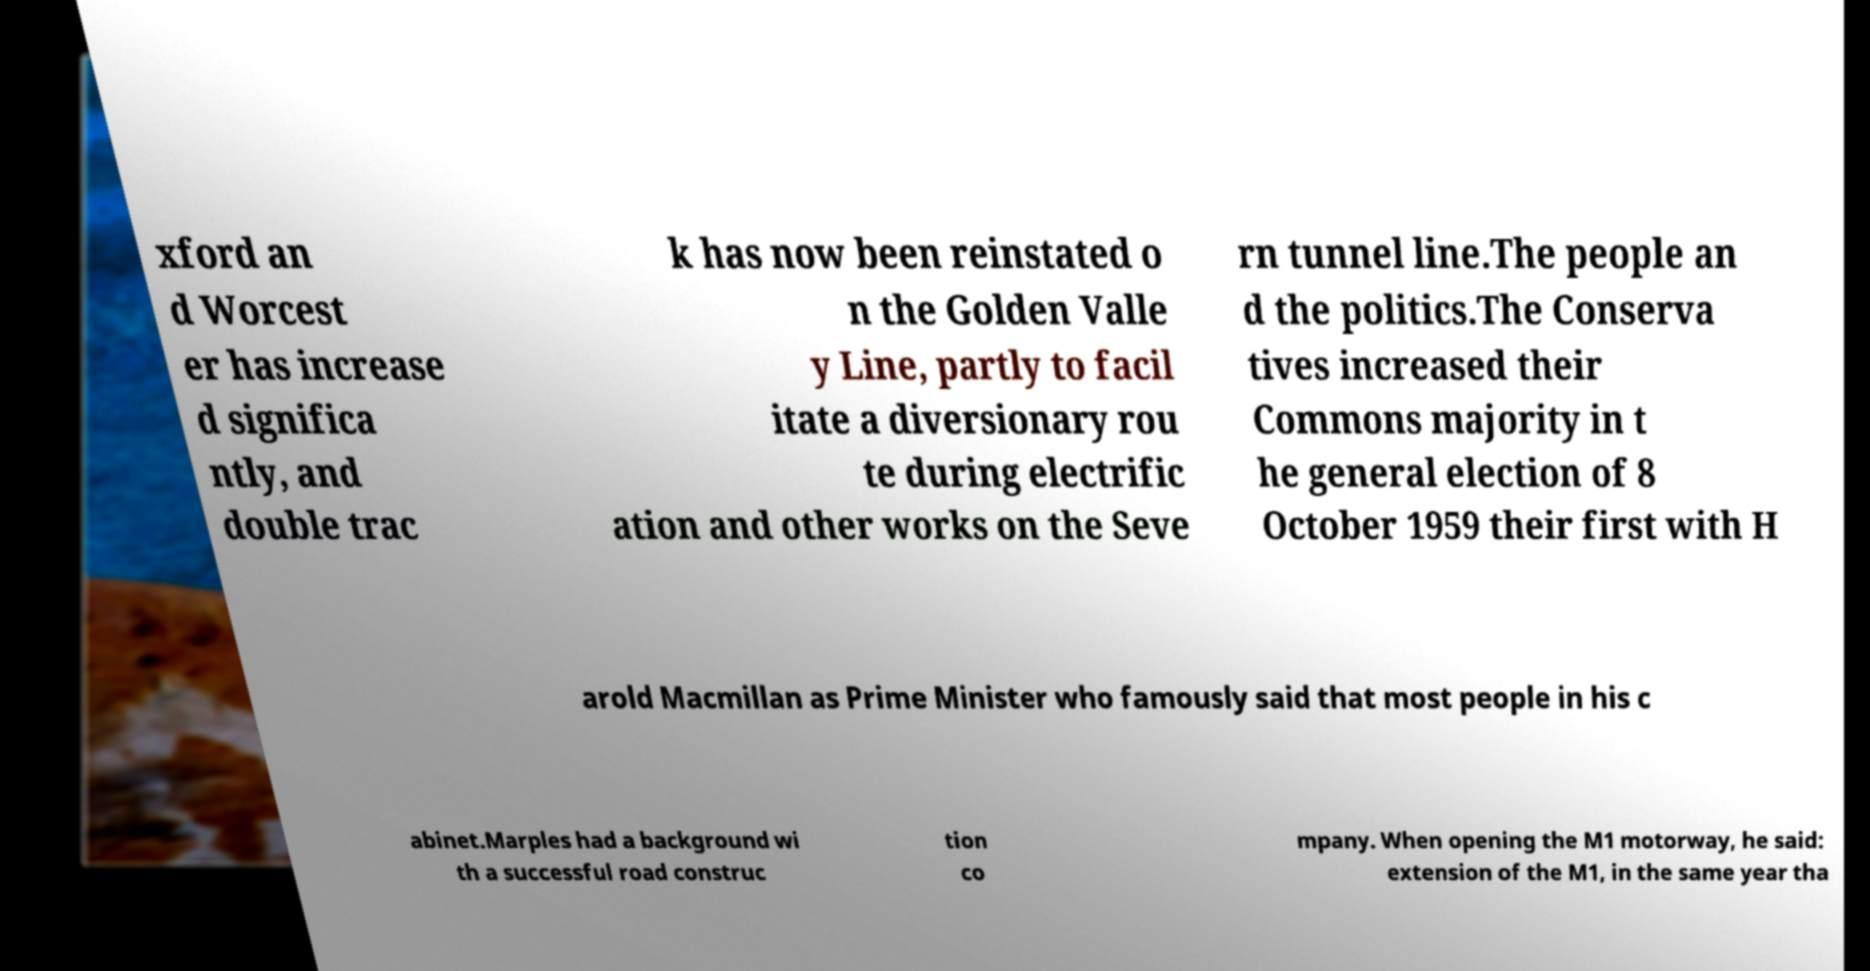Please read and relay the text visible in this image. What does it say? xford an d Worcest er has increase d significa ntly, and double trac k has now been reinstated o n the Golden Valle y Line, partly to facil itate a diversionary rou te during electrific ation and other works on the Seve rn tunnel line.The people an d the politics.The Conserva tives increased their Commons majority in t he general election of 8 October 1959 their first with H arold Macmillan as Prime Minister who famously said that most people in his c abinet.Marples had a background wi th a successful road construc tion co mpany. When opening the M1 motorway, he said: extension of the M1, in the same year tha 